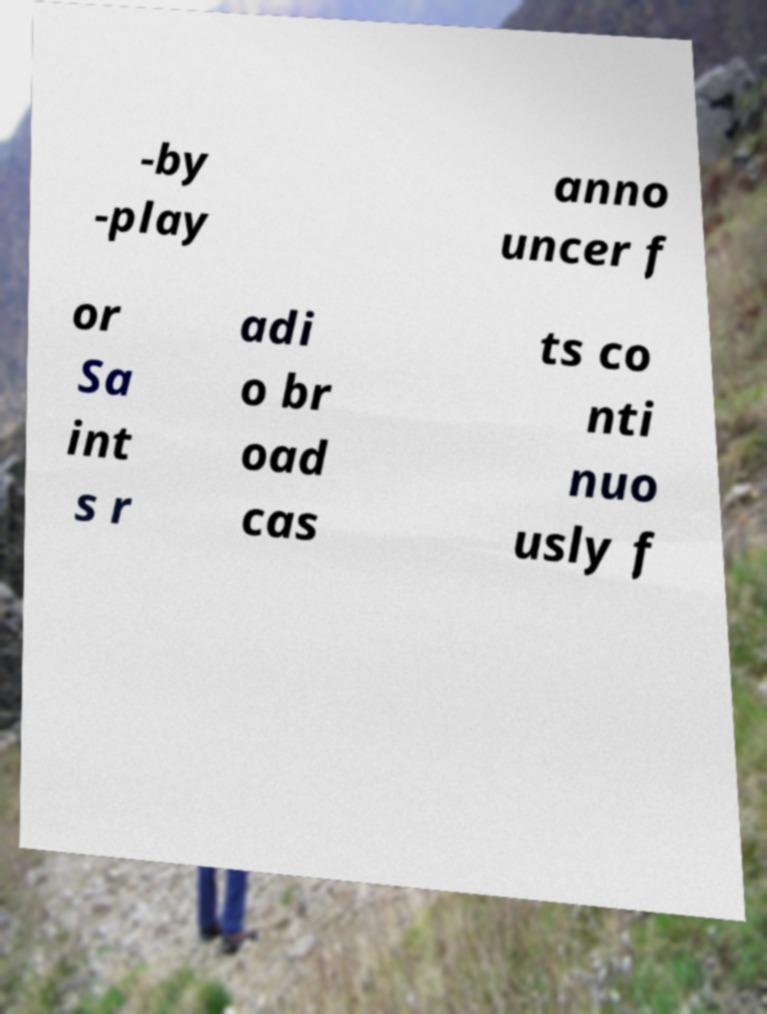Please read and relay the text visible in this image. What does it say? -by -play anno uncer f or Sa int s r adi o br oad cas ts co nti nuo usly f 